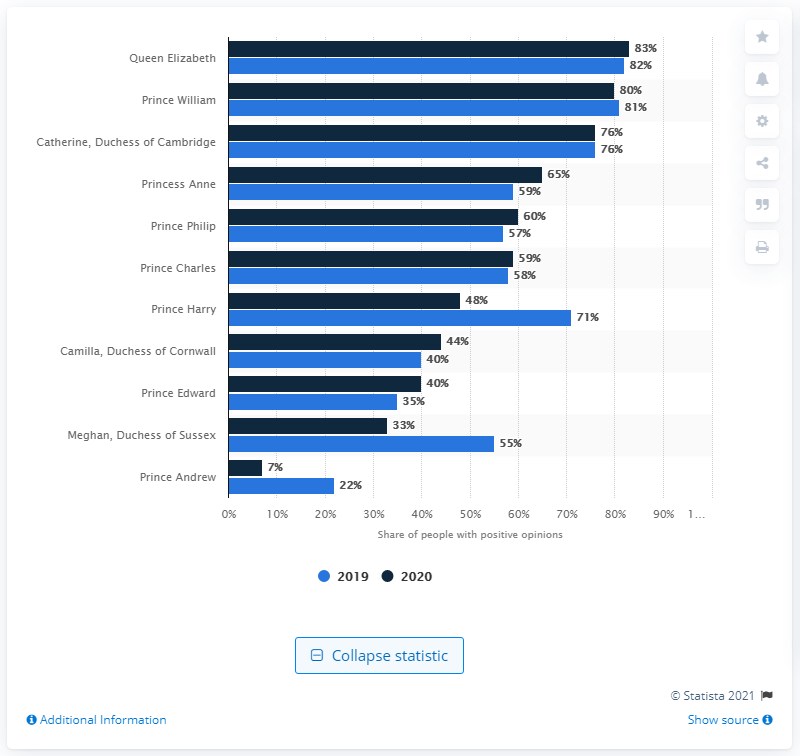Indicate a few pertinent items in this graphic. The Queen of the United Kingdom, Her Majesty Queen Elizabeth II, is widely considered to be the most popular member of the British Royal Family. The name of Elizabeth's grandson is Prince William. 